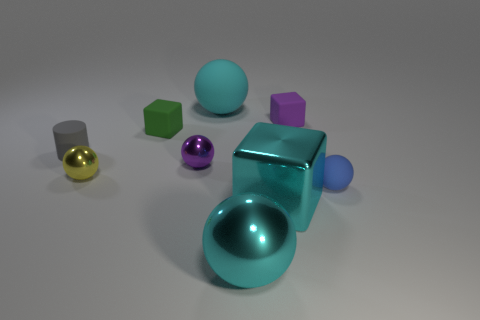Subtract all purple spheres. How many spheres are left? 4 Subtract all cyan cubes. How many cubes are left? 2 Subtract all cylinders. How many objects are left? 8 Subtract all large red balls. Subtract all small rubber cylinders. How many objects are left? 8 Add 3 purple shiny objects. How many purple shiny objects are left? 4 Add 7 large gray rubber things. How many large gray rubber things exist? 7 Subtract 1 cyan cubes. How many objects are left? 8 Subtract 1 blocks. How many blocks are left? 2 Subtract all gray blocks. Subtract all green cylinders. How many blocks are left? 3 Subtract all yellow balls. How many purple blocks are left? 1 